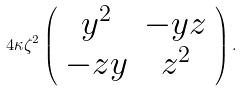Convert formula to latex. <formula><loc_0><loc_0><loc_500><loc_500>4 \kappa \zeta ^ { 2 } \left ( \begin{array} { c c } y ^ { 2 } & - y z \\ - z y & z ^ { 2 } \end{array} \right ) .</formula> 